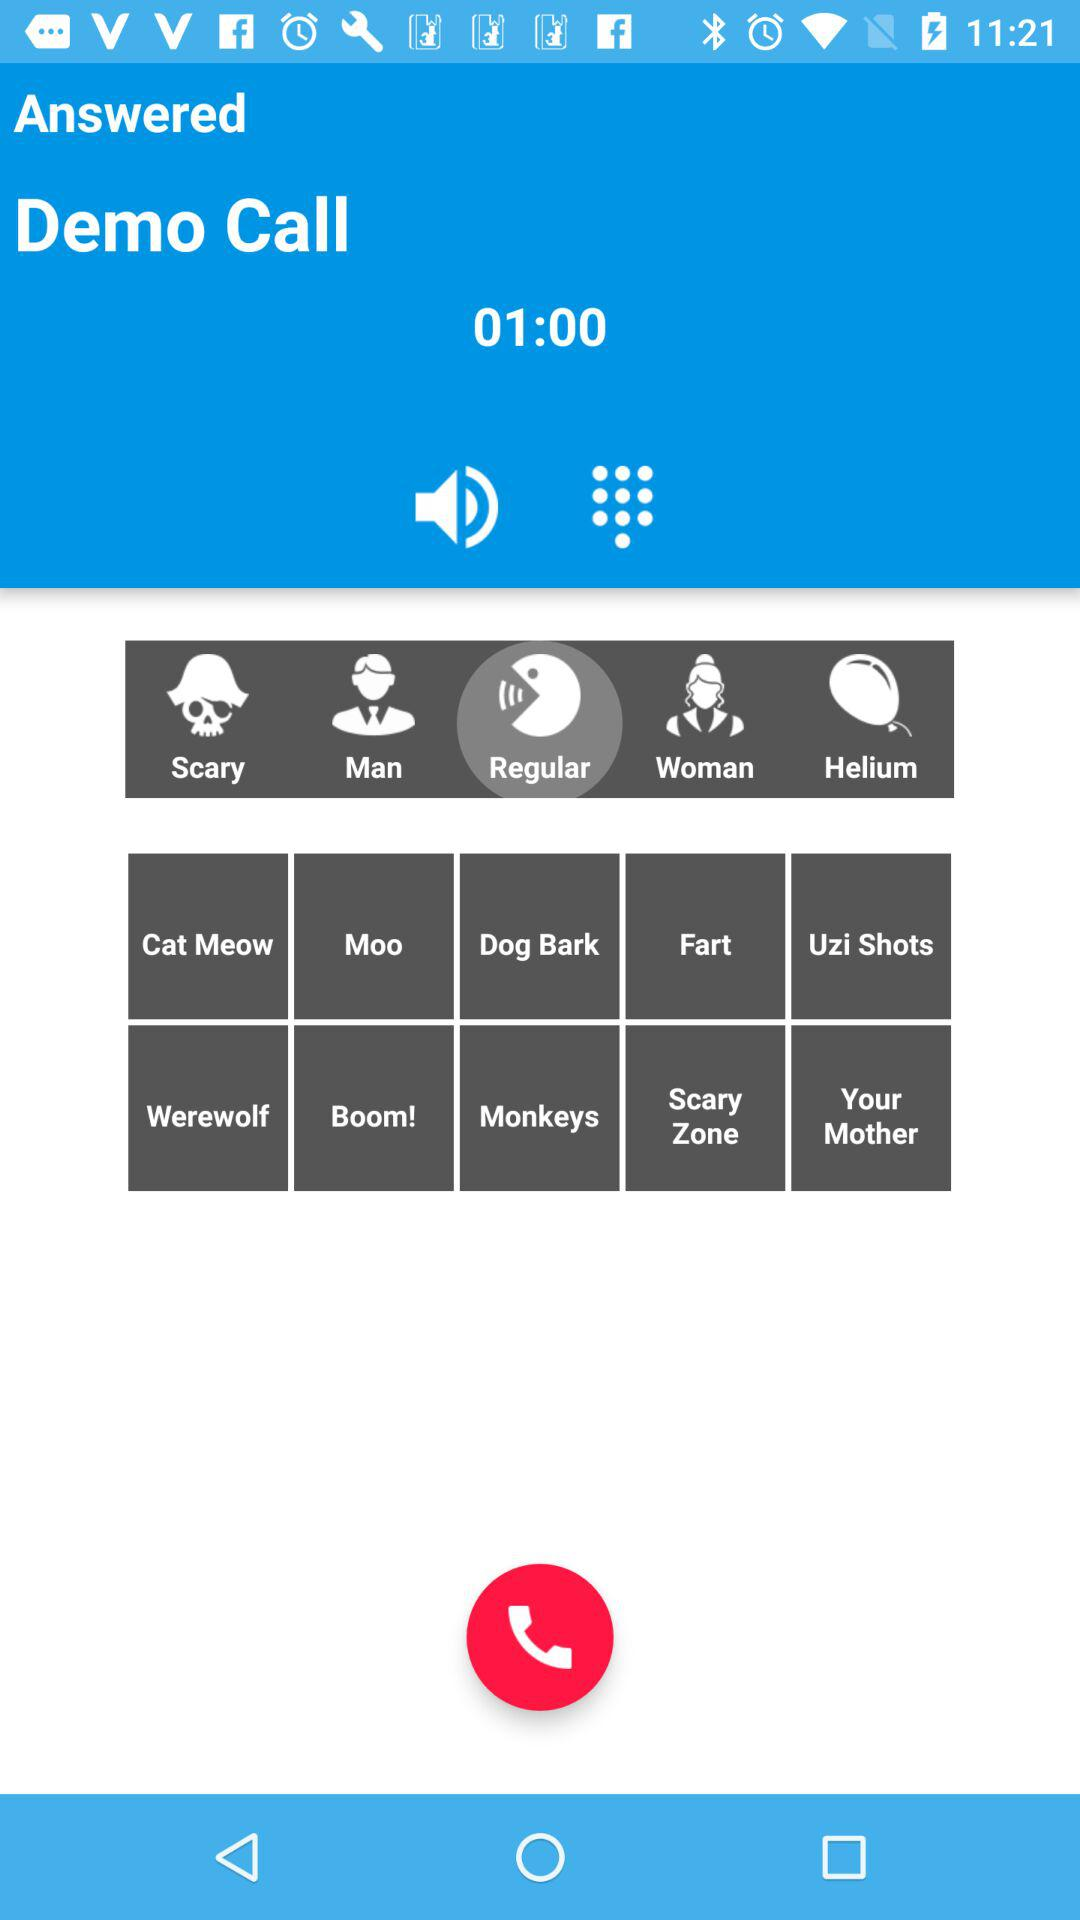Which option is selected? The selected option is "Regular". 